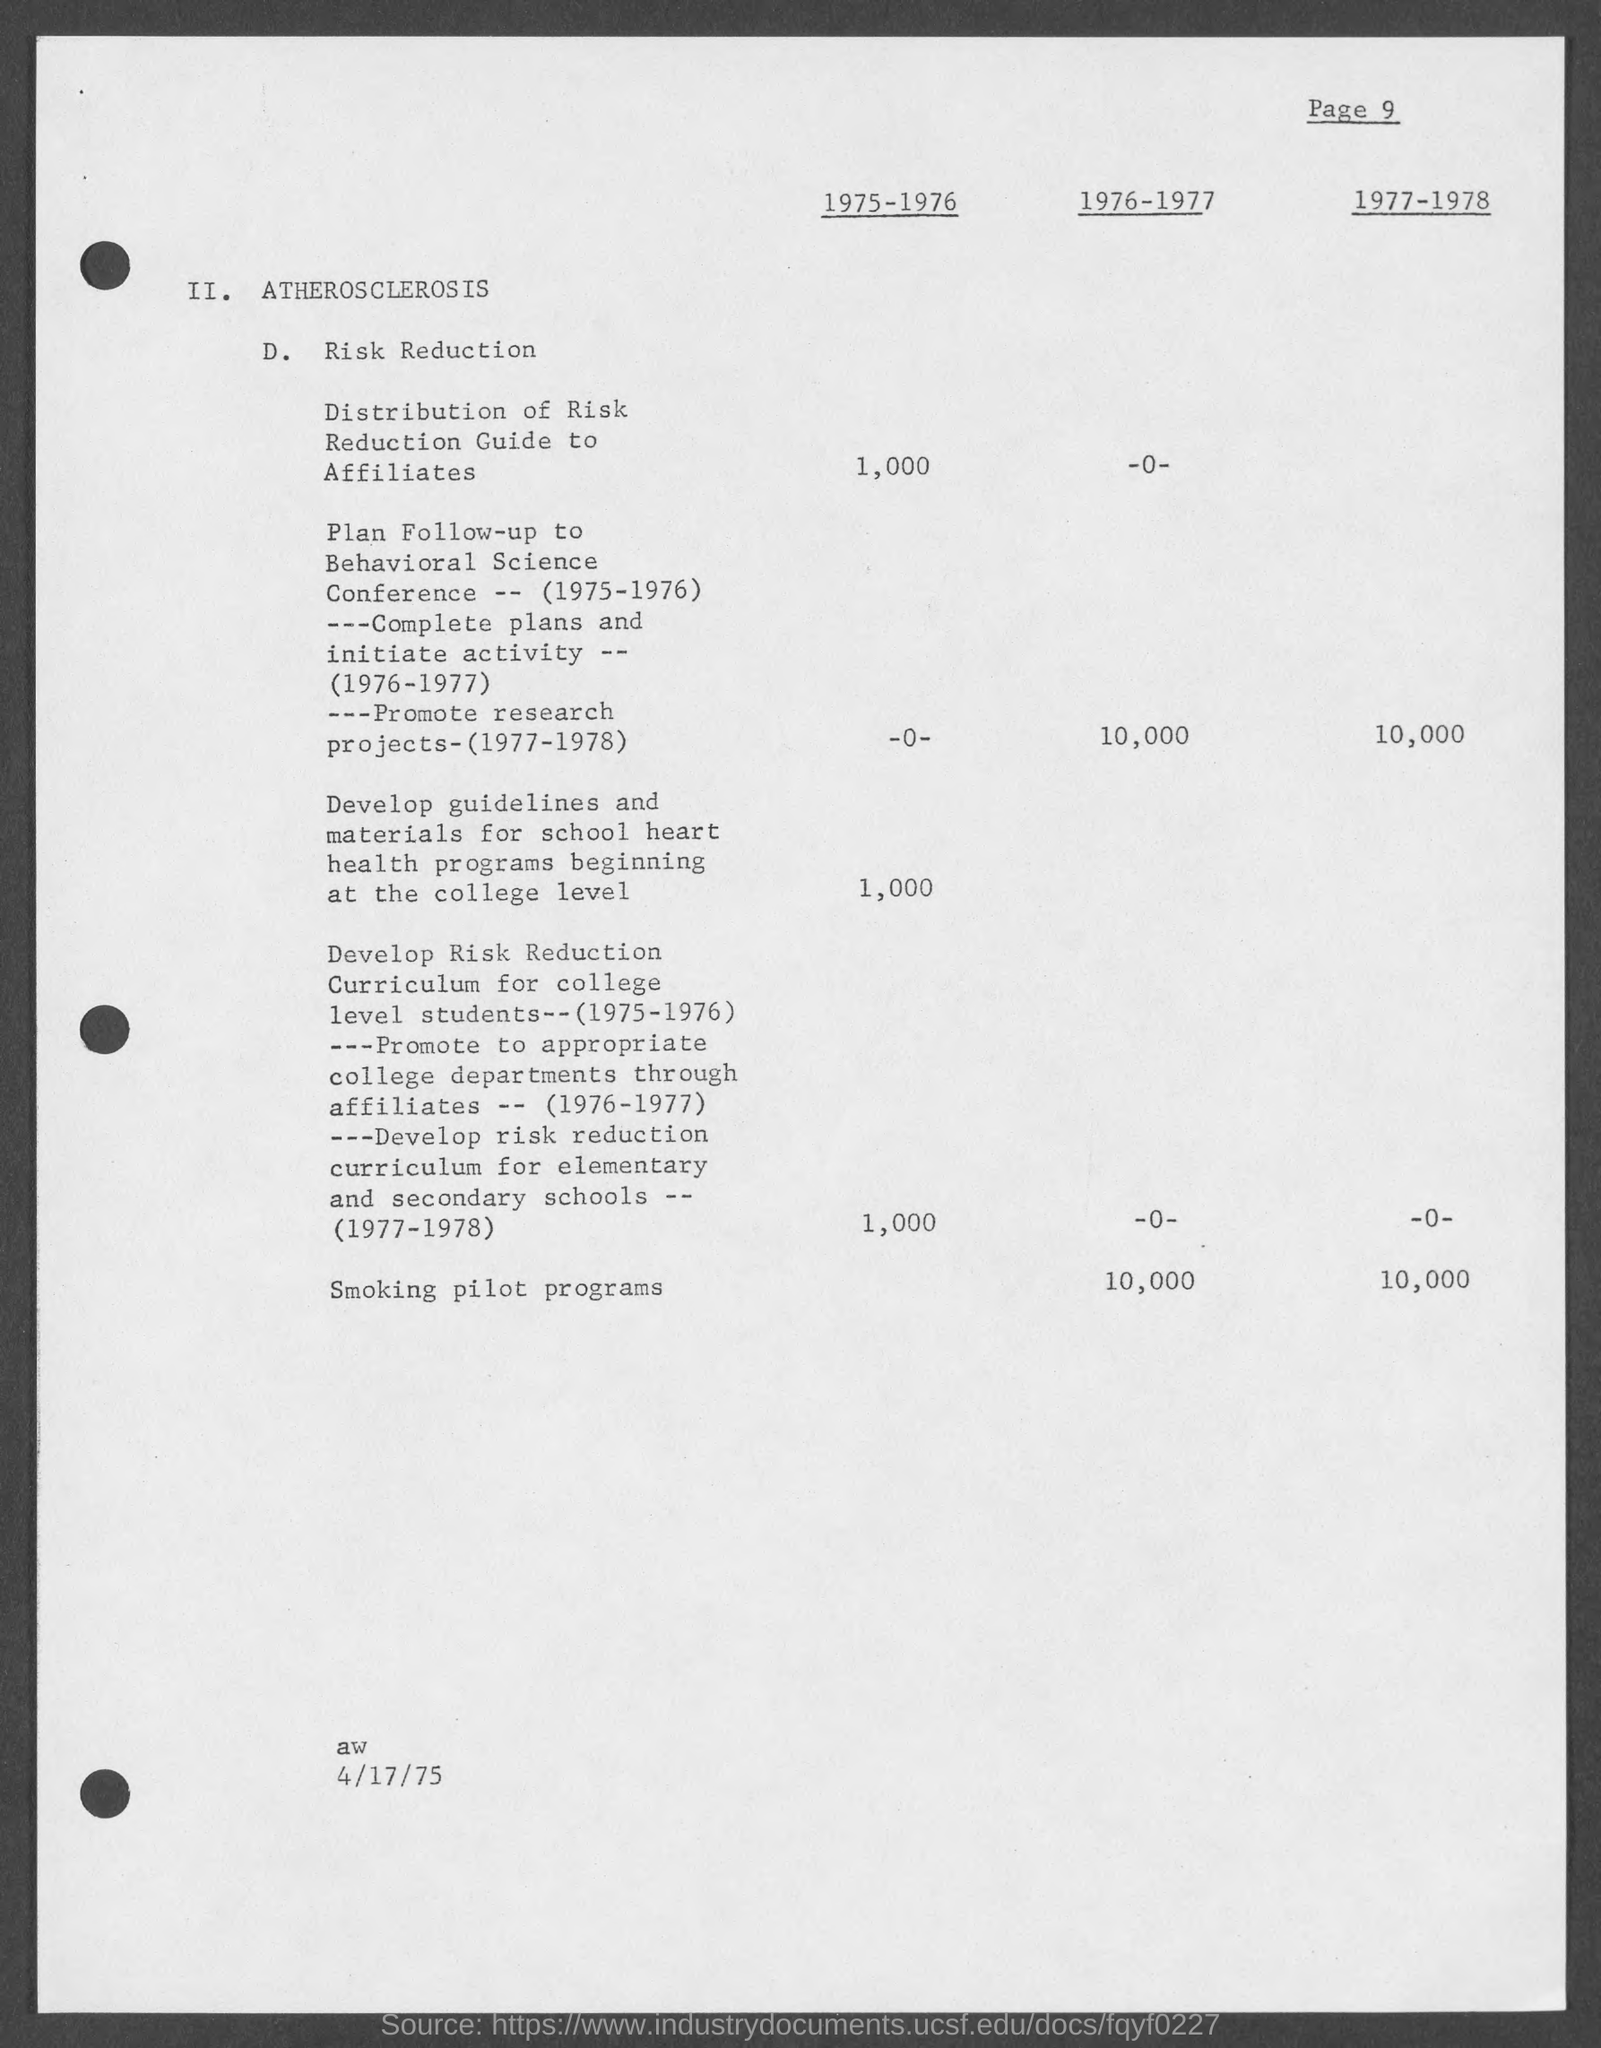What is the date at bottom of the page?
Provide a short and direct response. 4/17/75. How many smoking pilot programs are conducted between 1976-1977?
Give a very brief answer. 10,000. How many smoking pilot programs are conducted between 1977-1978?
Provide a short and direct response. 10,000. 